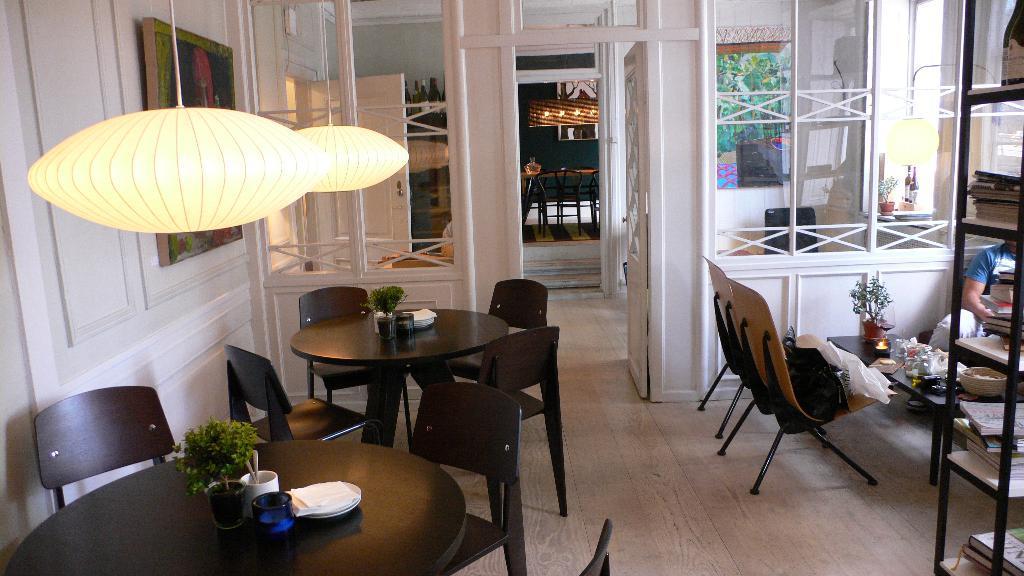Could you give a brief overview of what you see in this image? In this image I can see there are two tables at left side and there are lights attached to the ceiling. There is a bookshelf at right side and there is a man sitting at the right side and there are few doors and windows. 